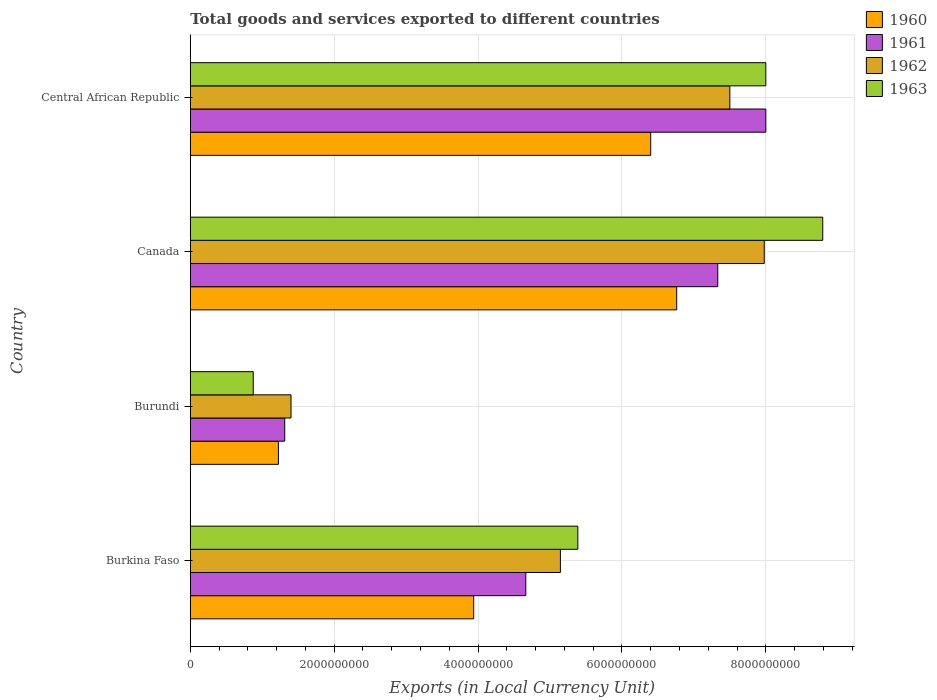How many different coloured bars are there?
Your answer should be compact. 4. How many groups of bars are there?
Provide a succinct answer. 4. Are the number of bars per tick equal to the number of legend labels?
Offer a very short reply. Yes. How many bars are there on the 4th tick from the bottom?
Offer a terse response. 4. What is the label of the 2nd group of bars from the top?
Provide a short and direct response. Canada. What is the Amount of goods and services exports in 1963 in Burkina Faso?
Your response must be concise. 5.39e+09. Across all countries, what is the maximum Amount of goods and services exports in 1962?
Your response must be concise. 7.98e+09. Across all countries, what is the minimum Amount of goods and services exports in 1963?
Your response must be concise. 8.75e+08. In which country was the Amount of goods and services exports in 1962 maximum?
Give a very brief answer. Canada. In which country was the Amount of goods and services exports in 1963 minimum?
Give a very brief answer. Burundi. What is the total Amount of goods and services exports in 1961 in the graph?
Give a very brief answer. 2.13e+1. What is the difference between the Amount of goods and services exports in 1962 in Burundi and that in Canada?
Provide a succinct answer. -6.58e+09. What is the difference between the Amount of goods and services exports in 1962 in Burundi and the Amount of goods and services exports in 1960 in Canada?
Give a very brief answer. -5.36e+09. What is the average Amount of goods and services exports in 1963 per country?
Your response must be concise. 5.76e+09. What is the difference between the Amount of goods and services exports in 1963 and Amount of goods and services exports in 1960 in Central African Republic?
Your answer should be very brief. 1.60e+09. In how many countries, is the Amount of goods and services exports in 1962 greater than 4800000000 LCU?
Make the answer very short. 3. What is the ratio of the Amount of goods and services exports in 1962 in Burkina Faso to that in Central African Republic?
Keep it short and to the point. 0.69. Is the difference between the Amount of goods and services exports in 1963 in Burkina Faso and Canada greater than the difference between the Amount of goods and services exports in 1960 in Burkina Faso and Canada?
Your response must be concise. No. What is the difference between the highest and the second highest Amount of goods and services exports in 1963?
Offer a very short reply. 7.91e+08. What is the difference between the highest and the lowest Amount of goods and services exports in 1960?
Keep it short and to the point. 5.54e+09. In how many countries, is the Amount of goods and services exports in 1962 greater than the average Amount of goods and services exports in 1962 taken over all countries?
Your answer should be compact. 2. Is it the case that in every country, the sum of the Amount of goods and services exports in 1960 and Amount of goods and services exports in 1963 is greater than the sum of Amount of goods and services exports in 1962 and Amount of goods and services exports in 1961?
Keep it short and to the point. No. What does the 4th bar from the bottom in Burundi represents?
Provide a succinct answer. 1963. Is it the case that in every country, the sum of the Amount of goods and services exports in 1960 and Amount of goods and services exports in 1963 is greater than the Amount of goods and services exports in 1962?
Provide a succinct answer. Yes. How many bars are there?
Offer a very short reply. 16. Are all the bars in the graph horizontal?
Keep it short and to the point. Yes. How many countries are there in the graph?
Your answer should be very brief. 4. Does the graph contain any zero values?
Your answer should be compact. No. Where does the legend appear in the graph?
Offer a terse response. Top right. How many legend labels are there?
Provide a short and direct response. 4. How are the legend labels stacked?
Provide a short and direct response. Vertical. What is the title of the graph?
Offer a very short reply. Total goods and services exported to different countries. Does "1979" appear as one of the legend labels in the graph?
Your response must be concise. No. What is the label or title of the X-axis?
Your answer should be compact. Exports (in Local Currency Unit). What is the Exports (in Local Currency Unit) of 1960 in Burkina Faso?
Make the answer very short. 3.94e+09. What is the Exports (in Local Currency Unit) of 1961 in Burkina Faso?
Give a very brief answer. 4.66e+09. What is the Exports (in Local Currency Unit) in 1962 in Burkina Faso?
Your response must be concise. 5.14e+09. What is the Exports (in Local Currency Unit) of 1963 in Burkina Faso?
Offer a terse response. 5.39e+09. What is the Exports (in Local Currency Unit) of 1960 in Burundi?
Offer a very short reply. 1.22e+09. What is the Exports (in Local Currency Unit) in 1961 in Burundi?
Offer a very short reply. 1.31e+09. What is the Exports (in Local Currency Unit) in 1962 in Burundi?
Offer a terse response. 1.40e+09. What is the Exports (in Local Currency Unit) in 1963 in Burundi?
Provide a short and direct response. 8.75e+08. What is the Exports (in Local Currency Unit) of 1960 in Canada?
Provide a succinct answer. 6.76e+09. What is the Exports (in Local Currency Unit) of 1961 in Canada?
Ensure brevity in your answer.  7.33e+09. What is the Exports (in Local Currency Unit) in 1962 in Canada?
Offer a terse response. 7.98e+09. What is the Exports (in Local Currency Unit) of 1963 in Canada?
Your response must be concise. 8.79e+09. What is the Exports (in Local Currency Unit) of 1960 in Central African Republic?
Keep it short and to the point. 6.40e+09. What is the Exports (in Local Currency Unit) in 1961 in Central African Republic?
Offer a terse response. 8.00e+09. What is the Exports (in Local Currency Unit) of 1962 in Central African Republic?
Give a very brief answer. 7.50e+09. What is the Exports (in Local Currency Unit) in 1963 in Central African Republic?
Your response must be concise. 8.00e+09. Across all countries, what is the maximum Exports (in Local Currency Unit) of 1960?
Your response must be concise. 6.76e+09. Across all countries, what is the maximum Exports (in Local Currency Unit) of 1961?
Provide a short and direct response. 8.00e+09. Across all countries, what is the maximum Exports (in Local Currency Unit) of 1962?
Your response must be concise. 7.98e+09. Across all countries, what is the maximum Exports (in Local Currency Unit) of 1963?
Your answer should be very brief. 8.79e+09. Across all countries, what is the minimum Exports (in Local Currency Unit) of 1960?
Give a very brief answer. 1.22e+09. Across all countries, what is the minimum Exports (in Local Currency Unit) of 1961?
Provide a short and direct response. 1.31e+09. Across all countries, what is the minimum Exports (in Local Currency Unit) in 1962?
Offer a very short reply. 1.40e+09. Across all countries, what is the minimum Exports (in Local Currency Unit) of 1963?
Offer a very short reply. 8.75e+08. What is the total Exports (in Local Currency Unit) in 1960 in the graph?
Keep it short and to the point. 1.83e+1. What is the total Exports (in Local Currency Unit) of 1961 in the graph?
Provide a succinct answer. 2.13e+1. What is the total Exports (in Local Currency Unit) of 1962 in the graph?
Your answer should be very brief. 2.20e+1. What is the total Exports (in Local Currency Unit) of 1963 in the graph?
Make the answer very short. 2.31e+1. What is the difference between the Exports (in Local Currency Unit) in 1960 in Burkina Faso and that in Burundi?
Your answer should be compact. 2.71e+09. What is the difference between the Exports (in Local Currency Unit) of 1961 in Burkina Faso and that in Burundi?
Offer a terse response. 3.35e+09. What is the difference between the Exports (in Local Currency Unit) in 1962 in Burkina Faso and that in Burundi?
Your answer should be very brief. 3.74e+09. What is the difference between the Exports (in Local Currency Unit) of 1963 in Burkina Faso and that in Burundi?
Provide a succinct answer. 4.51e+09. What is the difference between the Exports (in Local Currency Unit) of 1960 in Burkina Faso and that in Canada?
Your answer should be compact. -2.82e+09. What is the difference between the Exports (in Local Currency Unit) in 1961 in Burkina Faso and that in Canada?
Offer a very short reply. -2.67e+09. What is the difference between the Exports (in Local Currency Unit) in 1962 in Burkina Faso and that in Canada?
Give a very brief answer. -2.83e+09. What is the difference between the Exports (in Local Currency Unit) of 1963 in Burkina Faso and that in Canada?
Provide a succinct answer. -3.40e+09. What is the difference between the Exports (in Local Currency Unit) in 1960 in Burkina Faso and that in Central African Republic?
Keep it short and to the point. -2.46e+09. What is the difference between the Exports (in Local Currency Unit) in 1961 in Burkina Faso and that in Central African Republic?
Offer a very short reply. -3.34e+09. What is the difference between the Exports (in Local Currency Unit) in 1962 in Burkina Faso and that in Central African Republic?
Make the answer very short. -2.36e+09. What is the difference between the Exports (in Local Currency Unit) in 1963 in Burkina Faso and that in Central African Republic?
Ensure brevity in your answer.  -2.61e+09. What is the difference between the Exports (in Local Currency Unit) of 1960 in Burundi and that in Canada?
Give a very brief answer. -5.54e+09. What is the difference between the Exports (in Local Currency Unit) of 1961 in Burundi and that in Canada?
Provide a succinct answer. -6.02e+09. What is the difference between the Exports (in Local Currency Unit) in 1962 in Burundi and that in Canada?
Your answer should be very brief. -6.58e+09. What is the difference between the Exports (in Local Currency Unit) in 1963 in Burundi and that in Canada?
Make the answer very short. -7.92e+09. What is the difference between the Exports (in Local Currency Unit) in 1960 in Burundi and that in Central African Republic?
Keep it short and to the point. -5.18e+09. What is the difference between the Exports (in Local Currency Unit) of 1961 in Burundi and that in Central African Republic?
Make the answer very short. -6.69e+09. What is the difference between the Exports (in Local Currency Unit) of 1962 in Burundi and that in Central African Republic?
Give a very brief answer. -6.10e+09. What is the difference between the Exports (in Local Currency Unit) in 1963 in Burundi and that in Central African Republic?
Give a very brief answer. -7.12e+09. What is the difference between the Exports (in Local Currency Unit) of 1960 in Canada and that in Central African Republic?
Make the answer very short. 3.61e+08. What is the difference between the Exports (in Local Currency Unit) of 1961 in Canada and that in Central African Republic?
Your response must be concise. -6.68e+08. What is the difference between the Exports (in Local Currency Unit) of 1962 in Canada and that in Central African Republic?
Your answer should be very brief. 4.78e+08. What is the difference between the Exports (in Local Currency Unit) of 1963 in Canada and that in Central African Republic?
Your answer should be very brief. 7.91e+08. What is the difference between the Exports (in Local Currency Unit) of 1960 in Burkina Faso and the Exports (in Local Currency Unit) of 1961 in Burundi?
Your response must be concise. 2.63e+09. What is the difference between the Exports (in Local Currency Unit) of 1960 in Burkina Faso and the Exports (in Local Currency Unit) of 1962 in Burundi?
Provide a short and direct response. 2.54e+09. What is the difference between the Exports (in Local Currency Unit) of 1960 in Burkina Faso and the Exports (in Local Currency Unit) of 1963 in Burundi?
Offer a terse response. 3.06e+09. What is the difference between the Exports (in Local Currency Unit) in 1961 in Burkina Faso and the Exports (in Local Currency Unit) in 1962 in Burundi?
Keep it short and to the point. 3.26e+09. What is the difference between the Exports (in Local Currency Unit) in 1961 in Burkina Faso and the Exports (in Local Currency Unit) in 1963 in Burundi?
Give a very brief answer. 3.79e+09. What is the difference between the Exports (in Local Currency Unit) of 1962 in Burkina Faso and the Exports (in Local Currency Unit) of 1963 in Burundi?
Make the answer very short. 4.27e+09. What is the difference between the Exports (in Local Currency Unit) of 1960 in Burkina Faso and the Exports (in Local Currency Unit) of 1961 in Canada?
Offer a terse response. -3.39e+09. What is the difference between the Exports (in Local Currency Unit) in 1960 in Burkina Faso and the Exports (in Local Currency Unit) in 1962 in Canada?
Provide a succinct answer. -4.04e+09. What is the difference between the Exports (in Local Currency Unit) in 1960 in Burkina Faso and the Exports (in Local Currency Unit) in 1963 in Canada?
Your answer should be very brief. -4.85e+09. What is the difference between the Exports (in Local Currency Unit) of 1961 in Burkina Faso and the Exports (in Local Currency Unit) of 1962 in Canada?
Provide a short and direct response. -3.31e+09. What is the difference between the Exports (in Local Currency Unit) of 1961 in Burkina Faso and the Exports (in Local Currency Unit) of 1963 in Canada?
Offer a very short reply. -4.13e+09. What is the difference between the Exports (in Local Currency Unit) in 1962 in Burkina Faso and the Exports (in Local Currency Unit) in 1963 in Canada?
Offer a terse response. -3.65e+09. What is the difference between the Exports (in Local Currency Unit) of 1960 in Burkina Faso and the Exports (in Local Currency Unit) of 1961 in Central African Republic?
Offer a terse response. -4.06e+09. What is the difference between the Exports (in Local Currency Unit) of 1960 in Burkina Faso and the Exports (in Local Currency Unit) of 1962 in Central African Republic?
Your answer should be very brief. -3.56e+09. What is the difference between the Exports (in Local Currency Unit) in 1960 in Burkina Faso and the Exports (in Local Currency Unit) in 1963 in Central African Republic?
Your answer should be compact. -4.06e+09. What is the difference between the Exports (in Local Currency Unit) of 1961 in Burkina Faso and the Exports (in Local Currency Unit) of 1962 in Central African Republic?
Make the answer very short. -2.84e+09. What is the difference between the Exports (in Local Currency Unit) in 1961 in Burkina Faso and the Exports (in Local Currency Unit) in 1963 in Central African Republic?
Give a very brief answer. -3.34e+09. What is the difference between the Exports (in Local Currency Unit) of 1962 in Burkina Faso and the Exports (in Local Currency Unit) of 1963 in Central African Republic?
Make the answer very short. -2.86e+09. What is the difference between the Exports (in Local Currency Unit) of 1960 in Burundi and the Exports (in Local Currency Unit) of 1961 in Canada?
Provide a short and direct response. -6.11e+09. What is the difference between the Exports (in Local Currency Unit) of 1960 in Burundi and the Exports (in Local Currency Unit) of 1962 in Canada?
Offer a very short reply. -6.75e+09. What is the difference between the Exports (in Local Currency Unit) in 1960 in Burundi and the Exports (in Local Currency Unit) in 1963 in Canada?
Your answer should be very brief. -7.57e+09. What is the difference between the Exports (in Local Currency Unit) in 1961 in Burundi and the Exports (in Local Currency Unit) in 1962 in Canada?
Your answer should be compact. -6.67e+09. What is the difference between the Exports (in Local Currency Unit) in 1961 in Burundi and the Exports (in Local Currency Unit) in 1963 in Canada?
Make the answer very short. -7.48e+09. What is the difference between the Exports (in Local Currency Unit) of 1962 in Burundi and the Exports (in Local Currency Unit) of 1963 in Canada?
Offer a terse response. -7.39e+09. What is the difference between the Exports (in Local Currency Unit) of 1960 in Burundi and the Exports (in Local Currency Unit) of 1961 in Central African Republic?
Ensure brevity in your answer.  -6.78e+09. What is the difference between the Exports (in Local Currency Unit) of 1960 in Burundi and the Exports (in Local Currency Unit) of 1962 in Central African Republic?
Provide a short and direct response. -6.28e+09. What is the difference between the Exports (in Local Currency Unit) of 1960 in Burundi and the Exports (in Local Currency Unit) of 1963 in Central African Republic?
Offer a very short reply. -6.78e+09. What is the difference between the Exports (in Local Currency Unit) in 1961 in Burundi and the Exports (in Local Currency Unit) in 1962 in Central African Republic?
Ensure brevity in your answer.  -6.19e+09. What is the difference between the Exports (in Local Currency Unit) of 1961 in Burundi and the Exports (in Local Currency Unit) of 1963 in Central African Republic?
Offer a very short reply. -6.69e+09. What is the difference between the Exports (in Local Currency Unit) in 1962 in Burundi and the Exports (in Local Currency Unit) in 1963 in Central African Republic?
Make the answer very short. -6.60e+09. What is the difference between the Exports (in Local Currency Unit) in 1960 in Canada and the Exports (in Local Currency Unit) in 1961 in Central African Republic?
Offer a very short reply. -1.24e+09. What is the difference between the Exports (in Local Currency Unit) of 1960 in Canada and the Exports (in Local Currency Unit) of 1962 in Central African Republic?
Make the answer very short. -7.39e+08. What is the difference between the Exports (in Local Currency Unit) of 1960 in Canada and the Exports (in Local Currency Unit) of 1963 in Central African Republic?
Provide a succinct answer. -1.24e+09. What is the difference between the Exports (in Local Currency Unit) in 1961 in Canada and the Exports (in Local Currency Unit) in 1962 in Central African Republic?
Make the answer very short. -1.68e+08. What is the difference between the Exports (in Local Currency Unit) in 1961 in Canada and the Exports (in Local Currency Unit) in 1963 in Central African Republic?
Make the answer very short. -6.68e+08. What is the difference between the Exports (in Local Currency Unit) of 1962 in Canada and the Exports (in Local Currency Unit) of 1963 in Central African Republic?
Give a very brief answer. -2.17e+07. What is the average Exports (in Local Currency Unit) in 1960 per country?
Your answer should be compact. 4.58e+09. What is the average Exports (in Local Currency Unit) of 1961 per country?
Ensure brevity in your answer.  5.33e+09. What is the average Exports (in Local Currency Unit) of 1962 per country?
Your answer should be very brief. 5.51e+09. What is the average Exports (in Local Currency Unit) of 1963 per country?
Your answer should be very brief. 5.76e+09. What is the difference between the Exports (in Local Currency Unit) in 1960 and Exports (in Local Currency Unit) in 1961 in Burkina Faso?
Ensure brevity in your answer.  -7.24e+08. What is the difference between the Exports (in Local Currency Unit) of 1960 and Exports (in Local Currency Unit) of 1962 in Burkina Faso?
Provide a succinct answer. -1.21e+09. What is the difference between the Exports (in Local Currency Unit) in 1960 and Exports (in Local Currency Unit) in 1963 in Burkina Faso?
Your answer should be very brief. -1.45e+09. What is the difference between the Exports (in Local Currency Unit) in 1961 and Exports (in Local Currency Unit) in 1962 in Burkina Faso?
Make the answer very short. -4.81e+08. What is the difference between the Exports (in Local Currency Unit) of 1961 and Exports (in Local Currency Unit) of 1963 in Burkina Faso?
Keep it short and to the point. -7.23e+08. What is the difference between the Exports (in Local Currency Unit) of 1962 and Exports (in Local Currency Unit) of 1963 in Burkina Faso?
Your answer should be very brief. -2.42e+08. What is the difference between the Exports (in Local Currency Unit) of 1960 and Exports (in Local Currency Unit) of 1961 in Burundi?
Your answer should be compact. -8.75e+07. What is the difference between the Exports (in Local Currency Unit) in 1960 and Exports (in Local Currency Unit) in 1962 in Burundi?
Offer a terse response. -1.75e+08. What is the difference between the Exports (in Local Currency Unit) of 1960 and Exports (in Local Currency Unit) of 1963 in Burundi?
Your answer should be very brief. 3.50e+08. What is the difference between the Exports (in Local Currency Unit) in 1961 and Exports (in Local Currency Unit) in 1962 in Burundi?
Give a very brief answer. -8.75e+07. What is the difference between the Exports (in Local Currency Unit) in 1961 and Exports (in Local Currency Unit) in 1963 in Burundi?
Offer a terse response. 4.38e+08. What is the difference between the Exports (in Local Currency Unit) of 1962 and Exports (in Local Currency Unit) of 1963 in Burundi?
Offer a very short reply. 5.25e+08. What is the difference between the Exports (in Local Currency Unit) in 1960 and Exports (in Local Currency Unit) in 1961 in Canada?
Make the answer very short. -5.71e+08. What is the difference between the Exports (in Local Currency Unit) in 1960 and Exports (in Local Currency Unit) in 1962 in Canada?
Offer a terse response. -1.22e+09. What is the difference between the Exports (in Local Currency Unit) in 1960 and Exports (in Local Currency Unit) in 1963 in Canada?
Provide a short and direct response. -2.03e+09. What is the difference between the Exports (in Local Currency Unit) of 1961 and Exports (in Local Currency Unit) of 1962 in Canada?
Keep it short and to the point. -6.46e+08. What is the difference between the Exports (in Local Currency Unit) of 1961 and Exports (in Local Currency Unit) of 1963 in Canada?
Your answer should be very brief. -1.46e+09. What is the difference between the Exports (in Local Currency Unit) in 1962 and Exports (in Local Currency Unit) in 1963 in Canada?
Provide a short and direct response. -8.13e+08. What is the difference between the Exports (in Local Currency Unit) of 1960 and Exports (in Local Currency Unit) of 1961 in Central African Republic?
Offer a very short reply. -1.60e+09. What is the difference between the Exports (in Local Currency Unit) of 1960 and Exports (in Local Currency Unit) of 1962 in Central African Republic?
Give a very brief answer. -1.10e+09. What is the difference between the Exports (in Local Currency Unit) in 1960 and Exports (in Local Currency Unit) in 1963 in Central African Republic?
Provide a short and direct response. -1.60e+09. What is the difference between the Exports (in Local Currency Unit) in 1961 and Exports (in Local Currency Unit) in 1962 in Central African Republic?
Provide a short and direct response. 5.00e+08. What is the difference between the Exports (in Local Currency Unit) of 1962 and Exports (in Local Currency Unit) of 1963 in Central African Republic?
Give a very brief answer. -5.00e+08. What is the ratio of the Exports (in Local Currency Unit) of 1960 in Burkina Faso to that in Burundi?
Ensure brevity in your answer.  3.22. What is the ratio of the Exports (in Local Currency Unit) in 1961 in Burkina Faso to that in Burundi?
Provide a short and direct response. 3.55. What is the ratio of the Exports (in Local Currency Unit) of 1962 in Burkina Faso to that in Burundi?
Make the answer very short. 3.67. What is the ratio of the Exports (in Local Currency Unit) of 1963 in Burkina Faso to that in Burundi?
Give a very brief answer. 6.16. What is the ratio of the Exports (in Local Currency Unit) in 1960 in Burkina Faso to that in Canada?
Keep it short and to the point. 0.58. What is the ratio of the Exports (in Local Currency Unit) in 1961 in Burkina Faso to that in Canada?
Your answer should be very brief. 0.64. What is the ratio of the Exports (in Local Currency Unit) in 1962 in Burkina Faso to that in Canada?
Your answer should be compact. 0.64. What is the ratio of the Exports (in Local Currency Unit) of 1963 in Burkina Faso to that in Canada?
Offer a very short reply. 0.61. What is the ratio of the Exports (in Local Currency Unit) of 1960 in Burkina Faso to that in Central African Republic?
Your answer should be very brief. 0.62. What is the ratio of the Exports (in Local Currency Unit) in 1961 in Burkina Faso to that in Central African Republic?
Ensure brevity in your answer.  0.58. What is the ratio of the Exports (in Local Currency Unit) of 1962 in Burkina Faso to that in Central African Republic?
Keep it short and to the point. 0.69. What is the ratio of the Exports (in Local Currency Unit) in 1963 in Burkina Faso to that in Central African Republic?
Give a very brief answer. 0.67. What is the ratio of the Exports (in Local Currency Unit) of 1960 in Burundi to that in Canada?
Your response must be concise. 0.18. What is the ratio of the Exports (in Local Currency Unit) of 1961 in Burundi to that in Canada?
Offer a terse response. 0.18. What is the ratio of the Exports (in Local Currency Unit) of 1962 in Burundi to that in Canada?
Give a very brief answer. 0.18. What is the ratio of the Exports (in Local Currency Unit) in 1963 in Burundi to that in Canada?
Keep it short and to the point. 0.1. What is the ratio of the Exports (in Local Currency Unit) of 1960 in Burundi to that in Central African Republic?
Give a very brief answer. 0.19. What is the ratio of the Exports (in Local Currency Unit) in 1961 in Burundi to that in Central African Republic?
Offer a terse response. 0.16. What is the ratio of the Exports (in Local Currency Unit) of 1962 in Burundi to that in Central African Republic?
Your response must be concise. 0.19. What is the ratio of the Exports (in Local Currency Unit) in 1963 in Burundi to that in Central African Republic?
Your response must be concise. 0.11. What is the ratio of the Exports (in Local Currency Unit) in 1960 in Canada to that in Central African Republic?
Ensure brevity in your answer.  1.06. What is the ratio of the Exports (in Local Currency Unit) in 1961 in Canada to that in Central African Republic?
Offer a very short reply. 0.92. What is the ratio of the Exports (in Local Currency Unit) in 1962 in Canada to that in Central African Republic?
Make the answer very short. 1.06. What is the ratio of the Exports (in Local Currency Unit) in 1963 in Canada to that in Central African Republic?
Provide a succinct answer. 1.1. What is the difference between the highest and the second highest Exports (in Local Currency Unit) in 1960?
Give a very brief answer. 3.61e+08. What is the difference between the highest and the second highest Exports (in Local Currency Unit) of 1961?
Your response must be concise. 6.68e+08. What is the difference between the highest and the second highest Exports (in Local Currency Unit) in 1962?
Ensure brevity in your answer.  4.78e+08. What is the difference between the highest and the second highest Exports (in Local Currency Unit) of 1963?
Make the answer very short. 7.91e+08. What is the difference between the highest and the lowest Exports (in Local Currency Unit) in 1960?
Your answer should be compact. 5.54e+09. What is the difference between the highest and the lowest Exports (in Local Currency Unit) in 1961?
Give a very brief answer. 6.69e+09. What is the difference between the highest and the lowest Exports (in Local Currency Unit) in 1962?
Provide a short and direct response. 6.58e+09. What is the difference between the highest and the lowest Exports (in Local Currency Unit) in 1963?
Your answer should be compact. 7.92e+09. 